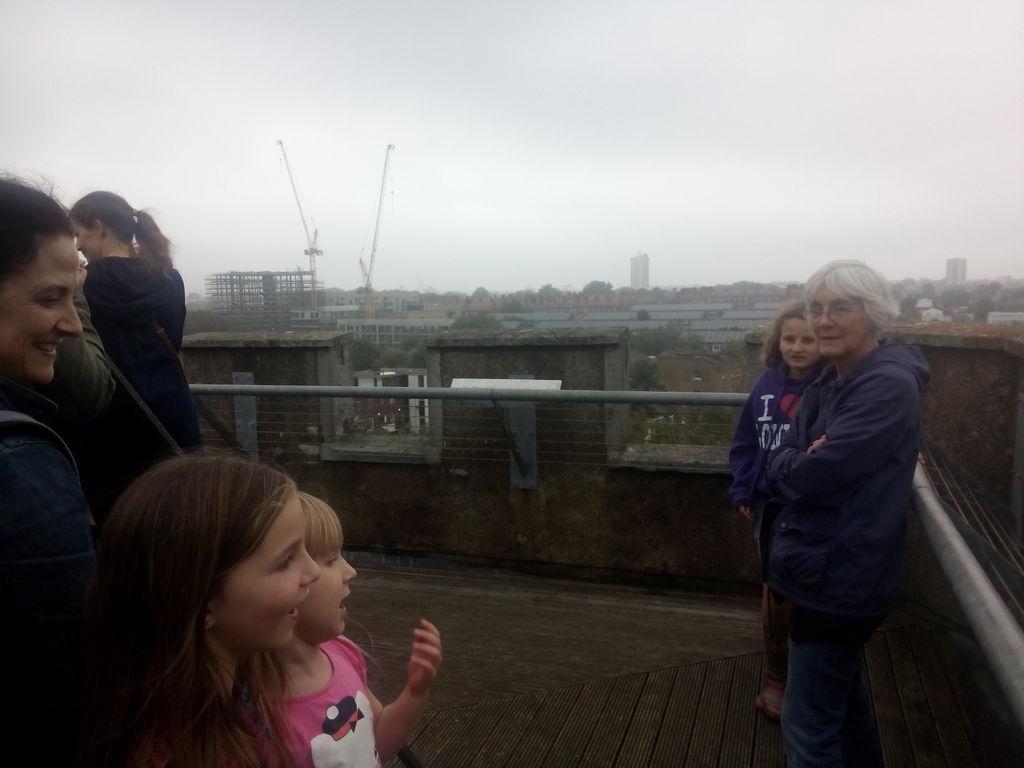Please provide a concise description of this image. In this image we can see some persons, railing and other objects. In the background of the image there are buildings, crane and other objects. At the top of the image there is the sky. At the bottom of the image there is the floor. 